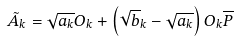Convert formula to latex. <formula><loc_0><loc_0><loc_500><loc_500>\tilde { A } _ { k } = \sqrt { a _ { k } } O _ { k } + \left ( \sqrt { b } _ { k } - \sqrt { a _ { k } } \right ) O _ { k } \overline { P } \,</formula> 